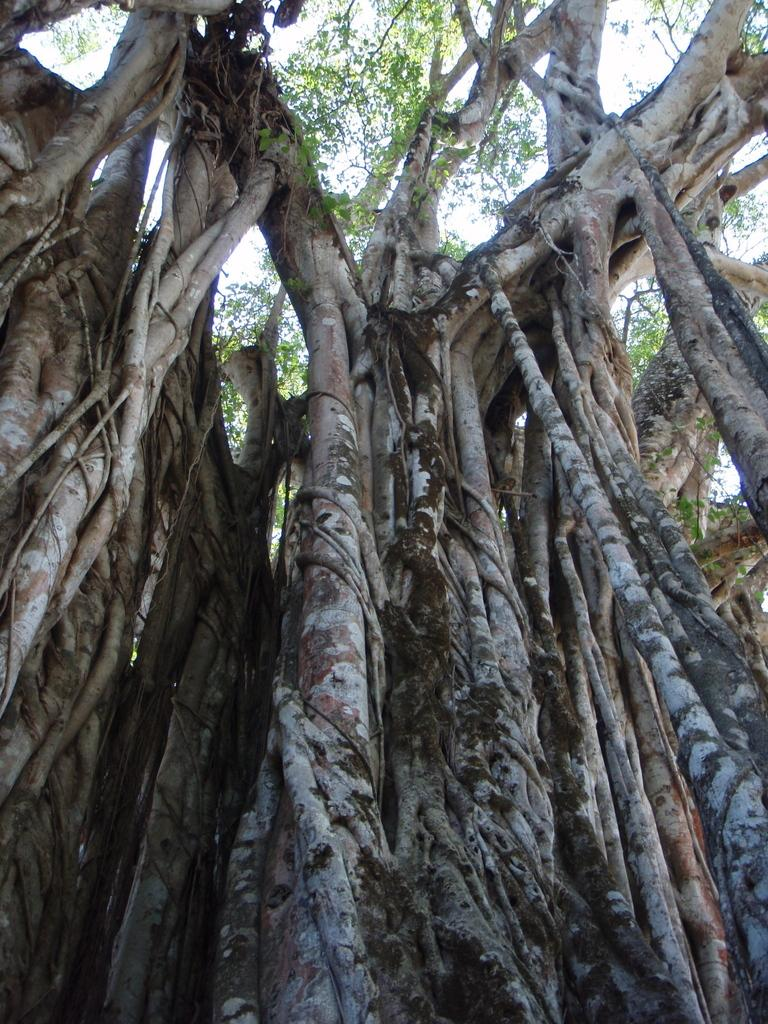What type of vegetation can be seen in the image? There are trees in the image. What features do the trees have? The trees have branches and leaves. What is visible in the background of the image? There are clouds in the sky in the background of the image. Can you tell me how many chickens are perched on the branches of the trees in the image? There are no chickens present in the image; it only features trees with branches and leaves. 